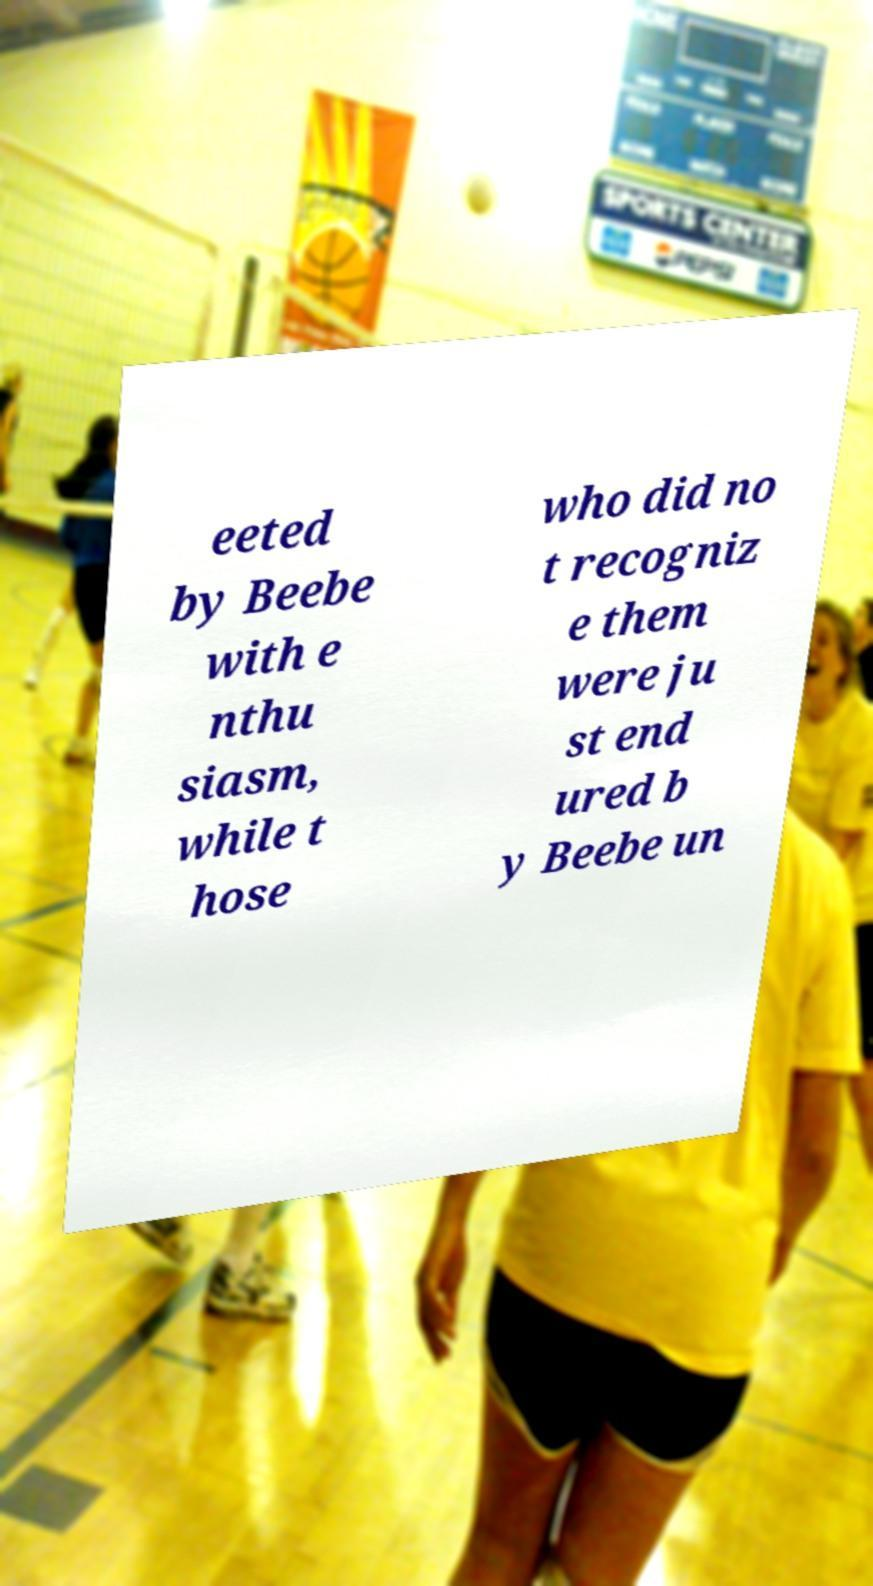Please read and relay the text visible in this image. What does it say? eeted by Beebe with e nthu siasm, while t hose who did no t recogniz e them were ju st end ured b y Beebe un 